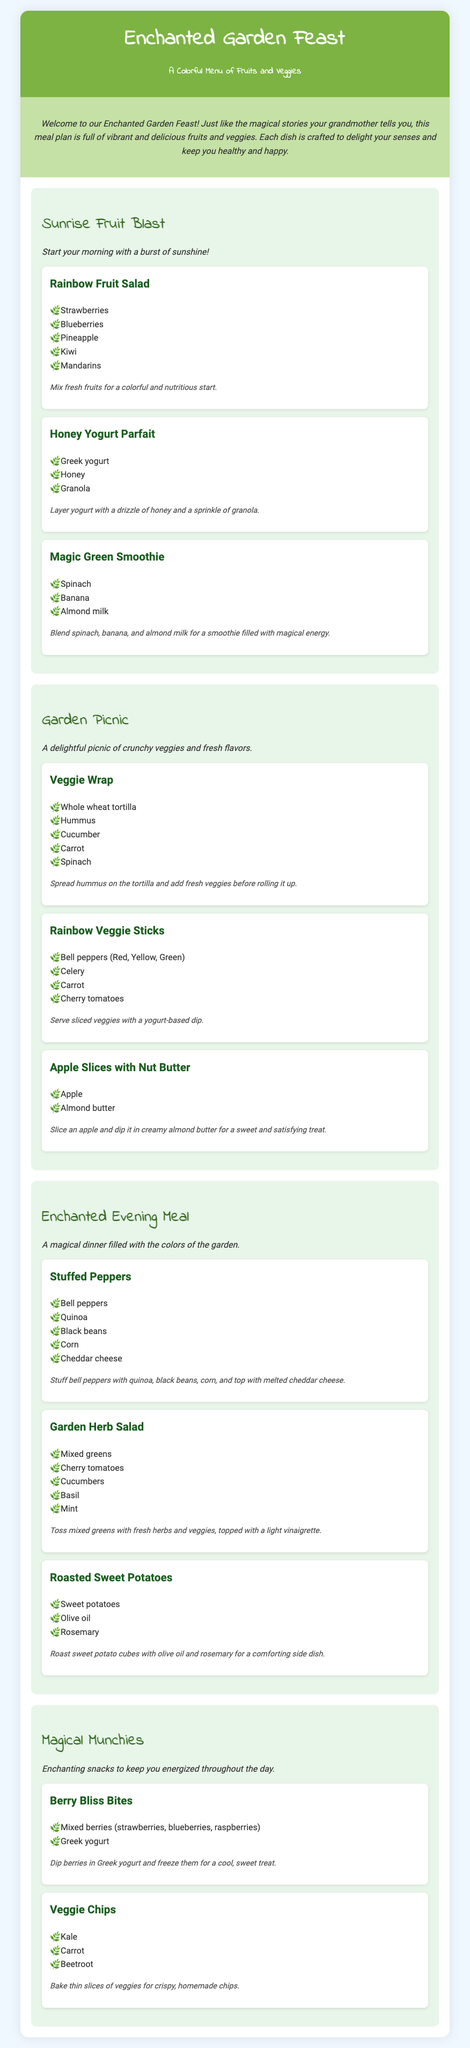What is the title of the meal plan? The title is indicated at the top of the document, naming the entire theme and concept.
Answer: Enchanted Garden Feast How many meals are included in the plan? The meals are listed separately, and by counting them, we find out the total number.
Answer: Four What is the main ingredient in the Magic Green Smoothie? The main ingredients are listed in the component description, specifically the first one mentioned.
Answer: Spinach What type of tortilla is used in the Veggie Wrap? The ingredient list specifies the type of tortilla used in the meal.
Answer: Whole wheat tortilla What is served with the Rainbow Veggie Sticks? The note mentions what to serve with the veggie sticks.
Answer: Yogurt-based dip What is the main ingredient in the Stuffed Peppers? The ingredient list for the Stuffed Peppers includes one key ingredient at the top.
Answer: Bell peppers What type of cheese is used in the Stuffed Peppers? The ingredient list for the Stuffed Peppers specifically includes this cheese.
Answer: Cheddar cheese What is the cooking method for the Veggie Chips? The note explains how to prepare the Veggie Chips, indicating the cooking method used.
Answer: Bake What is the purpose of the Magical Munchies section? The meal description explains the intent behind this section.
Answer: Snacks to keep you energized 